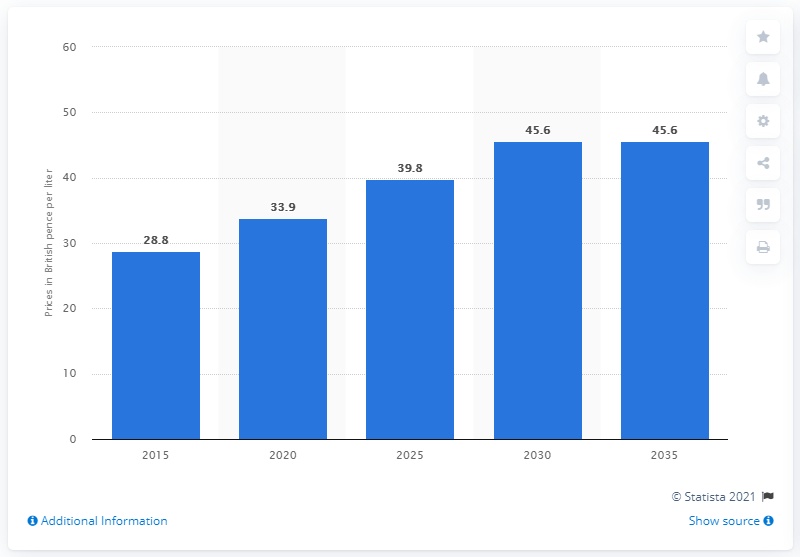Mention a couple of crucial points in this snapshot. The projected retail price of aviation kerosene in the UK is expected to reach 2035. 